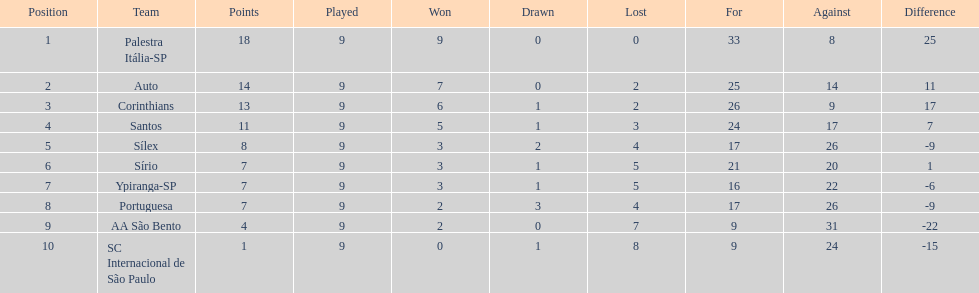Which team remained undefeated throughout the season? Palestra Itália-SP. 